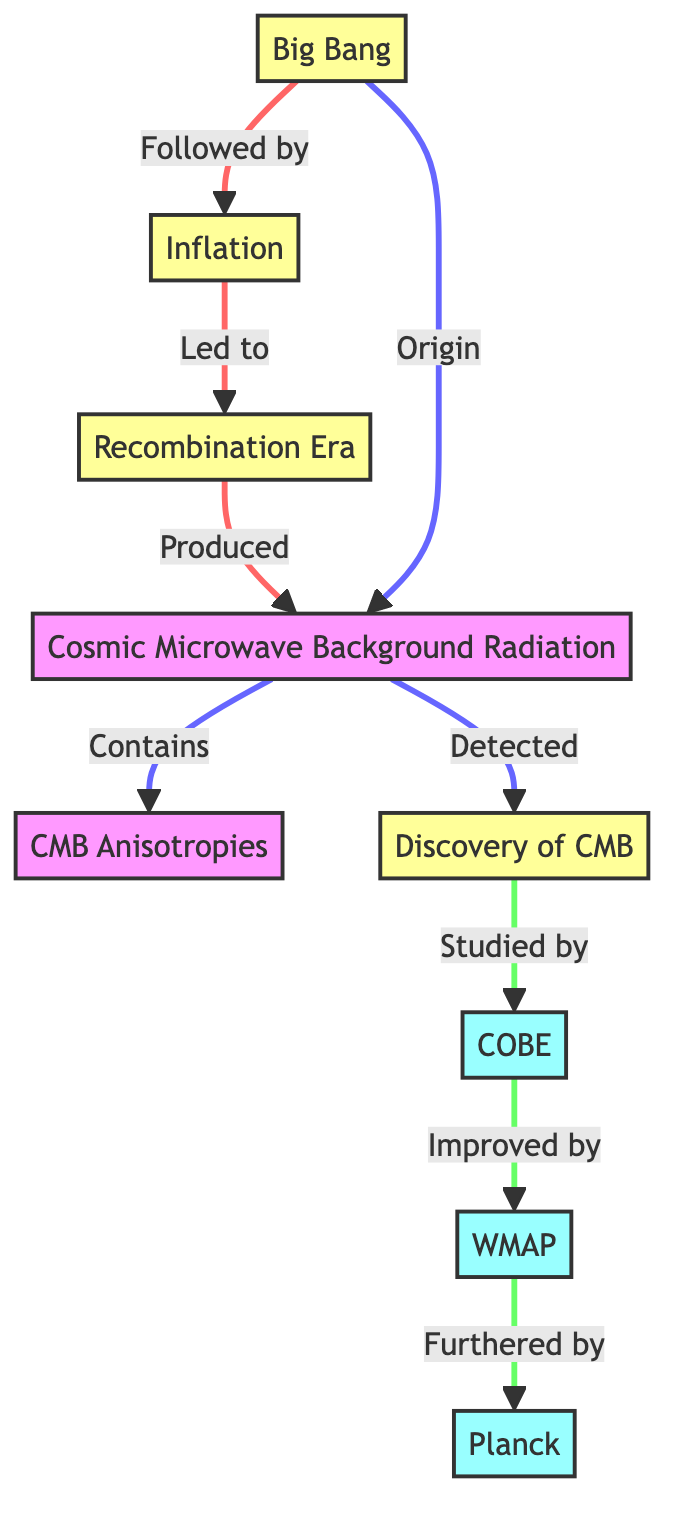What event followed the Big Bang? The diagram indicates that the event following the Big Bang is labeled "Inflation." It is clearly connected by an arrow pointing from Big Bang to Inflation.
Answer: Inflation How many satellites are represented in the diagram? The diagram shows three distinct satellites represented by nodes: COBE, WMAP, and Planck. Counting these nodes directly gives us the total number.
Answer: 3 What process produced the Cosmic Microwave Background Radiation? According to the diagram, the process that produced the Cosmic Microwave Background Radiation is the Recombination era, which is linked directly to the production of the CMBR.
Answer: Recombination Era What did the CMBR lead to in the diagram? The CMBR is depicted as leading to the detection marked by "Discovery of CMB." The link indicates a cause-effect relationship where CMBR caused its discovery.
Answer: Discovery of CMB Which satellite improved the studies conducted by COBE? The diagram shows a direct relationship where WMAP is described as having improved the results and studies conducted by COBE, as indicated by the arrow connecting the two nodes.
Answer: WMAP What do CMB anisotropies contain? The diagram specifies that the Cosmic Microwave Background Radiation contains CMB Anisotropies, denoted by a connecting line from CMBR to Anisotropies.
Answer: Anisotropies Which key event is indicated as the origin of the Cosmic Microwave Background Radiation? The diagram indicates that the Cosmic Microwave Background Radiation originated from the Big Bang, as shown by the direct link labeled "Origin."
Answer: Big Bang What is the chronological order of events starting from the Big Bang to the detection of the CMB? Tracing the arrows from the Big Bang sequentially goes to Inflation, then to Recombination, followed by the production of CMBR, and finally leading to the Discovery of CMB. Thus, the order is Big Bang, Inflation, Recombination, CMBR, Discovery of CMB.
Answer: Big Bang, Inflation, Recombination, CMBR, Discovery of CMB 